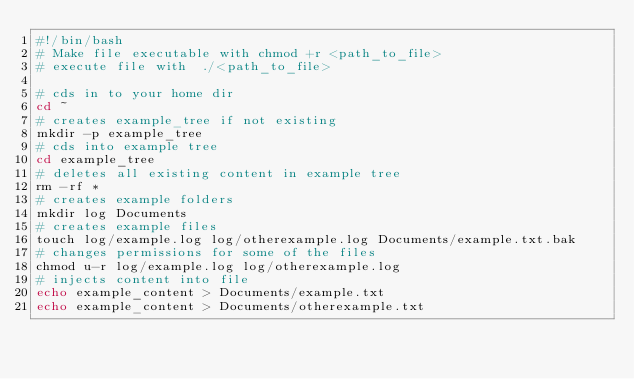<code> <loc_0><loc_0><loc_500><loc_500><_Bash_>#!/bin/bash
# Make file executable with chmod +r <path_to_file> 
# execute file with  ./<path_to_file>

# cds in to your home dir
cd ~
# creates example_tree if not existing
mkdir -p example_tree
# cds into example tree
cd example_tree
# deletes all existing content in example tree
rm -rf *
# creates example folders
mkdir log Documents
# creates example files
touch log/example.log log/otherexample.log Documents/example.txt.bak 
# changes permissions for some of the files
chmod u-r log/example.log log/otherexample.log
# injects content into file
echo example_content > Documents/example.txt
echo example_content > Documents/otherexample.txt</code> 